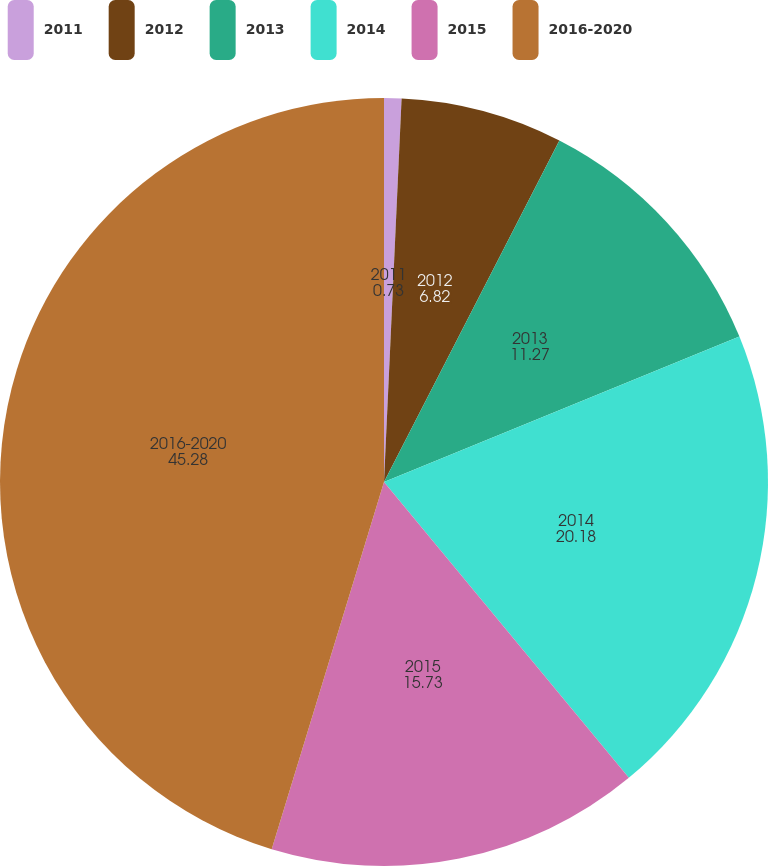Convert chart to OTSL. <chart><loc_0><loc_0><loc_500><loc_500><pie_chart><fcel>2011<fcel>2012<fcel>2013<fcel>2014<fcel>2015<fcel>2016-2020<nl><fcel>0.73%<fcel>6.82%<fcel>11.27%<fcel>20.18%<fcel>15.73%<fcel>45.28%<nl></chart> 